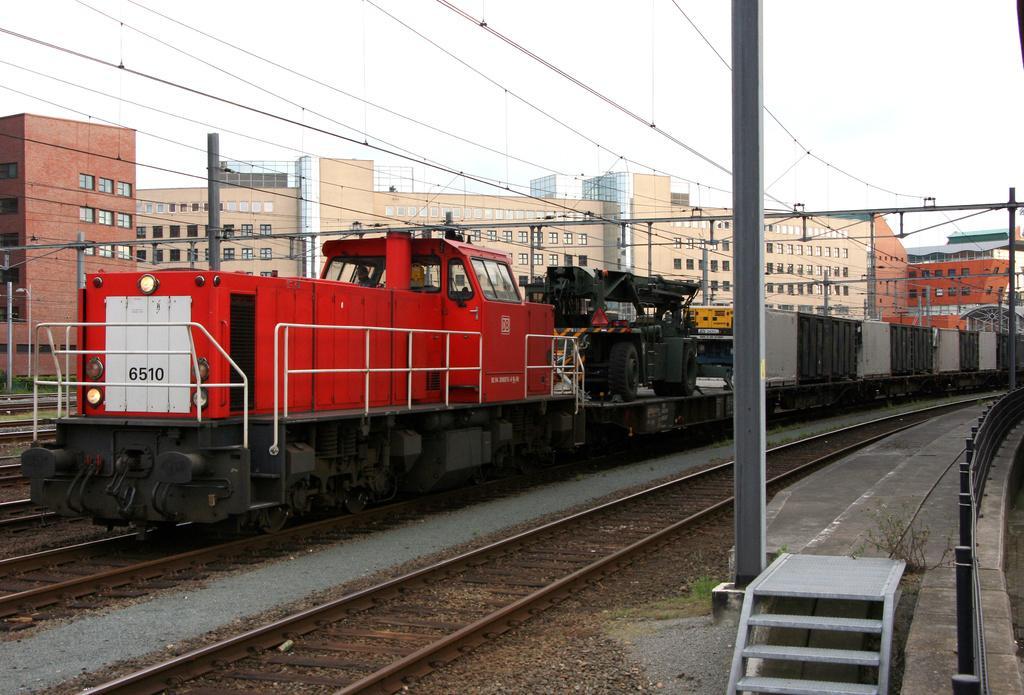Please provide a concise description of this image. Here, we can see some railway tracks, there is a red color train on the track, at the right side there is a pole and there are some silver color stairs and there is a platform, there are some electric cables, in the background there are some buildings and at the top there is a sky. 